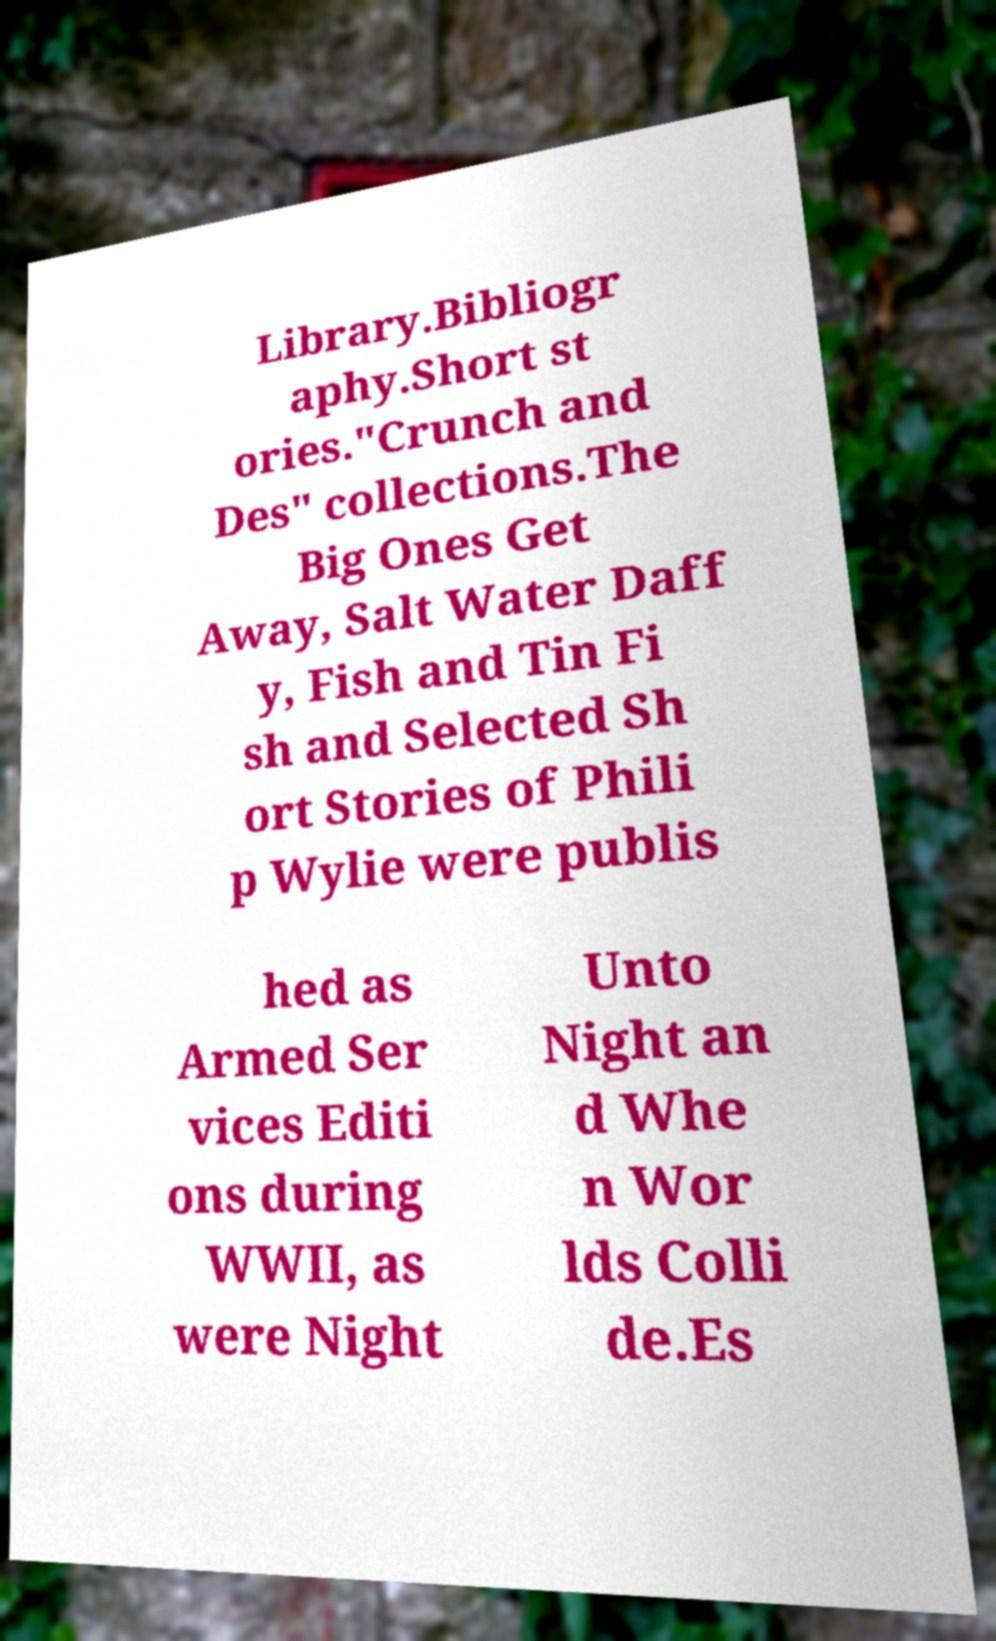I need the written content from this picture converted into text. Can you do that? Library.Bibliogr aphy.Short st ories."Crunch and Des" collections.The Big Ones Get Away, Salt Water Daff y, Fish and Tin Fi sh and Selected Sh ort Stories of Phili p Wylie were publis hed as Armed Ser vices Editi ons during WWII, as were Night Unto Night an d Whe n Wor lds Colli de.Es 